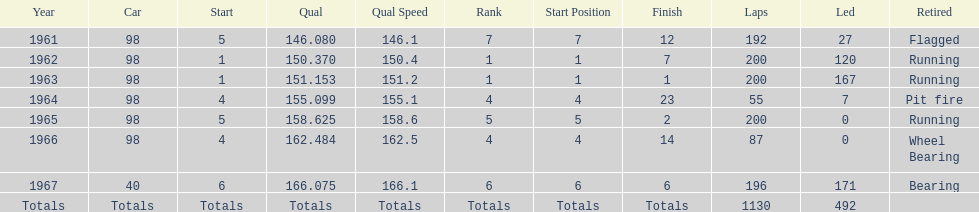How many consecutive years did parnelli place in the top 5? 5. 